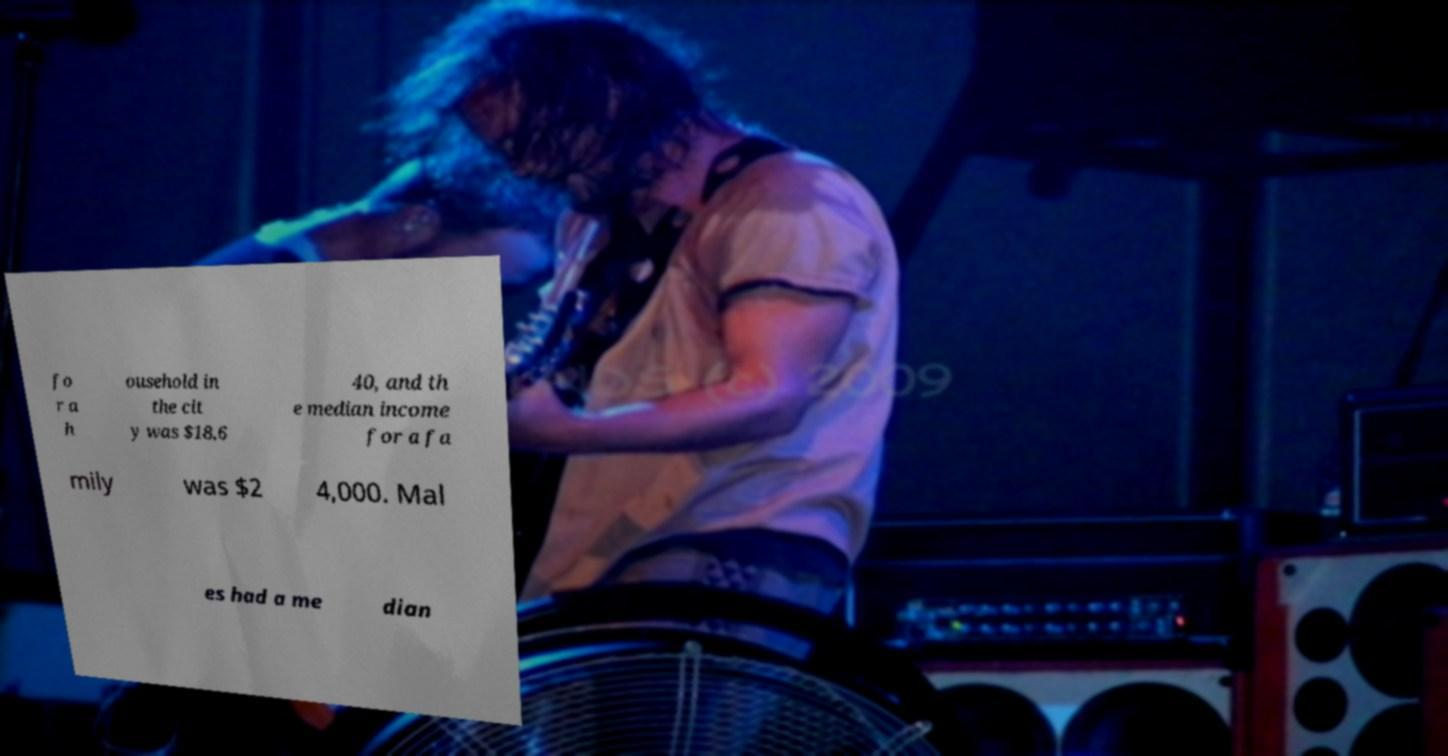Can you accurately transcribe the text from the provided image for me? fo r a h ousehold in the cit y was $18,6 40, and th e median income for a fa mily was $2 4,000. Mal es had a me dian 